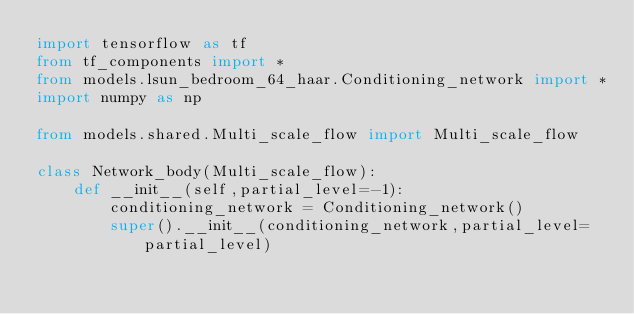Convert code to text. <code><loc_0><loc_0><loc_500><loc_500><_Python_>import tensorflow as tf
from tf_components import *
from models.lsun_bedroom_64_haar.Conditioning_network import *
import numpy as np

from models.shared.Multi_scale_flow import Multi_scale_flow

class Network_body(Multi_scale_flow):
	def __init__(self,partial_level=-1):
		conditioning_network = Conditioning_network()
		super().__init__(conditioning_network,partial_level=partial_level)
</code> 